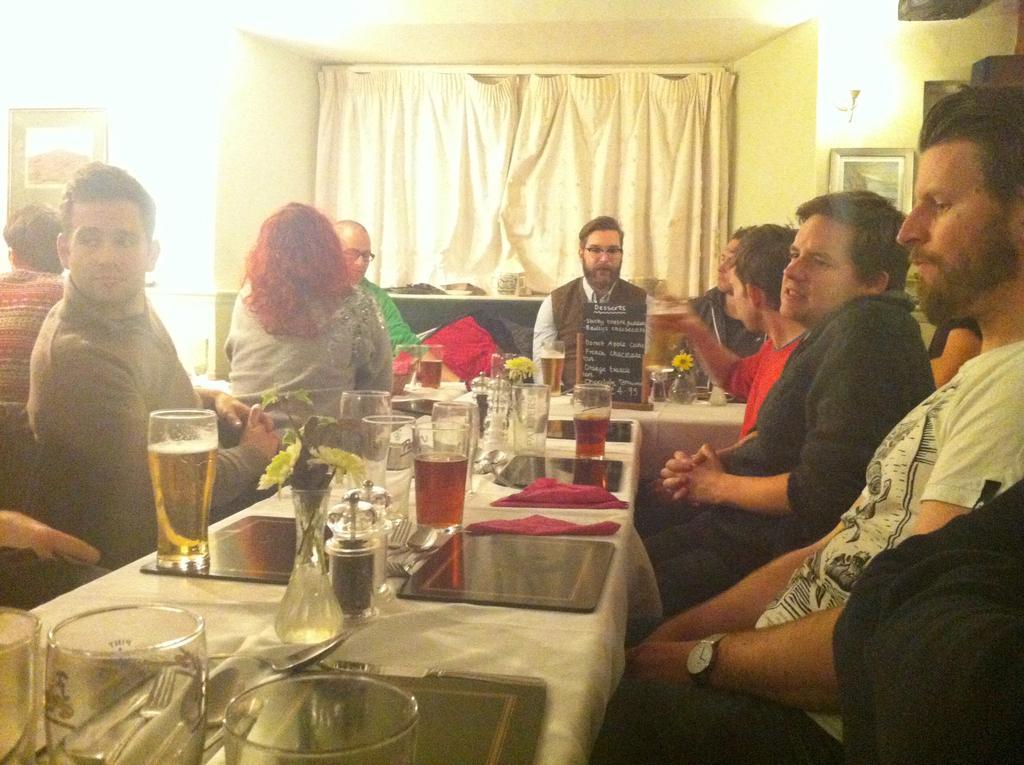Describe this image in one or two sentences. In this image there are group of people sitting on the chair. In front of people there is table. On the table there is a glass,flower pot,cloth,spoon,knife. At the background there is a wall and a curtain. The frame is attached to the wall. 